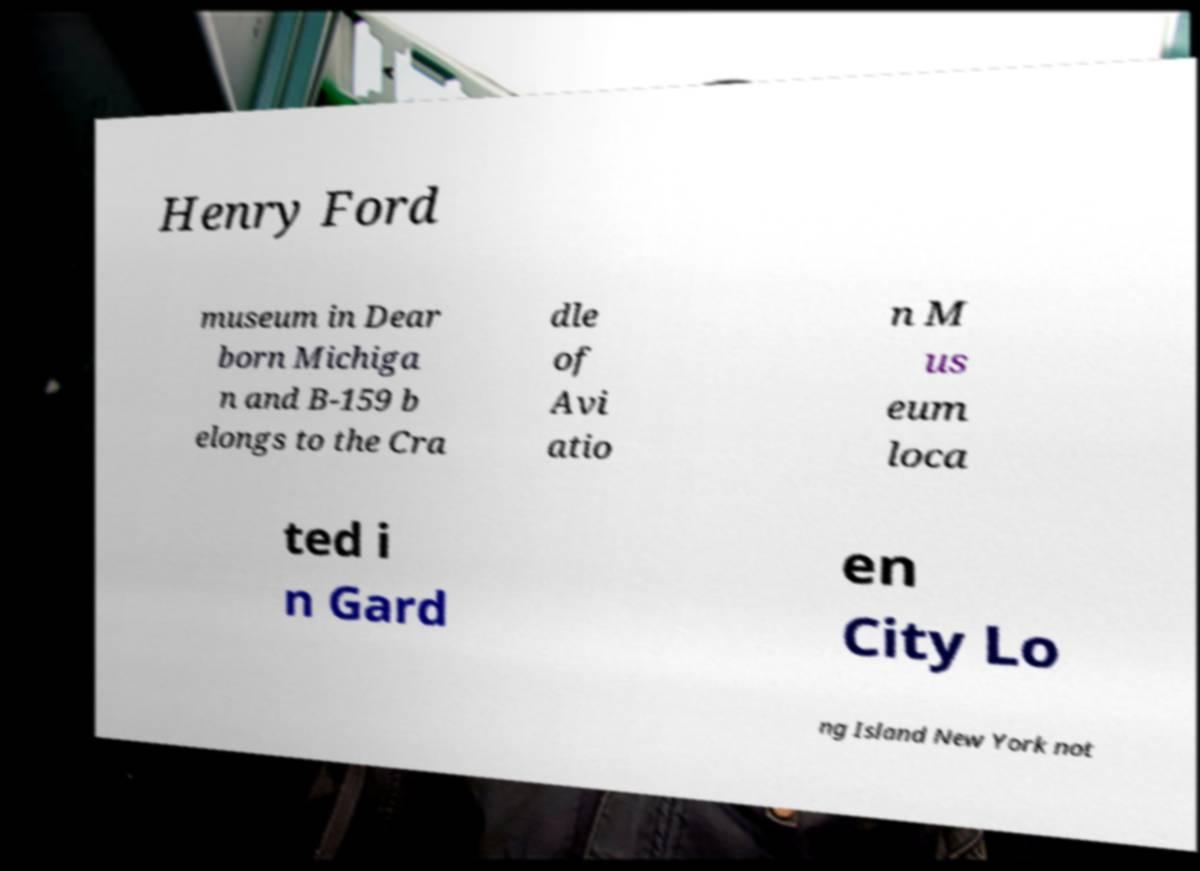Please read and relay the text visible in this image. What does it say? Henry Ford museum in Dear born Michiga n and B-159 b elongs to the Cra dle of Avi atio n M us eum loca ted i n Gard en City Lo ng Island New York not 